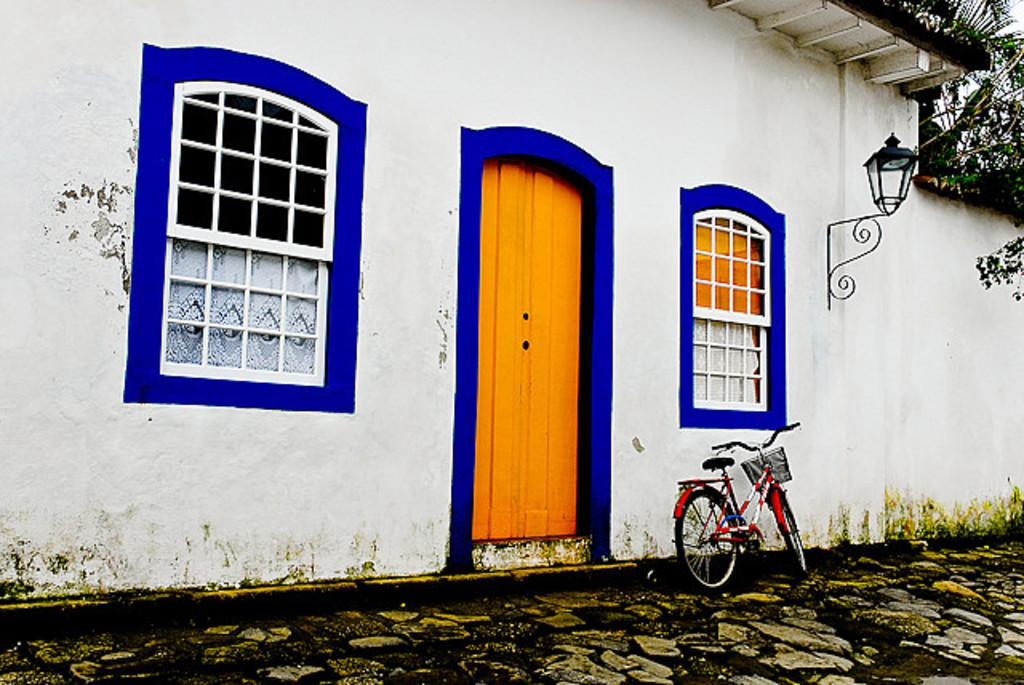What type of structure is present in the image? There is a building in the image. What is the color of the building? The building is white. What architectural features can be seen on the building? There are windows and a door on the building. What is the color of the windows and door? The windows are orange, and the door is orange. What natural elements are visible in the image? There are trees visible in the image. Where are the trees located in the image? The trees are in the right top of the image. What additional feature can be seen in the right top of the image? There is a hanging porch in the right top of the image. What type of kettle is being used by the spy in the image? There is no kettle or spy present in the image. 